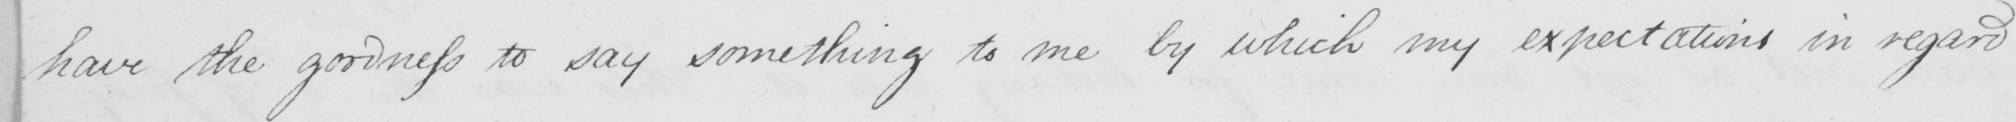What is written in this line of handwriting? have the goodness to say something to me by which my expectations in regard 